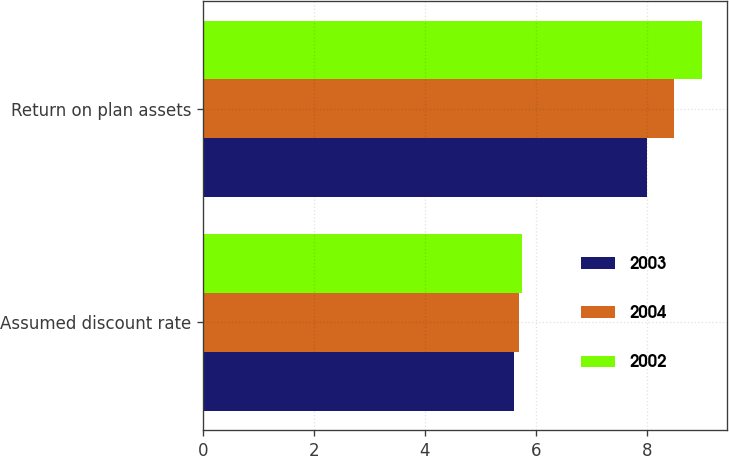<chart> <loc_0><loc_0><loc_500><loc_500><stacked_bar_chart><ecel><fcel>Assumed discount rate<fcel>Return on plan assets<nl><fcel>2003<fcel>5.6<fcel>8<nl><fcel>2004<fcel>5.7<fcel>8.5<nl><fcel>2002<fcel>5.75<fcel>9<nl></chart> 